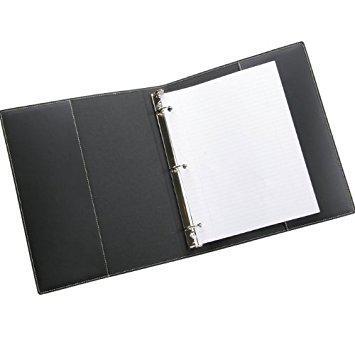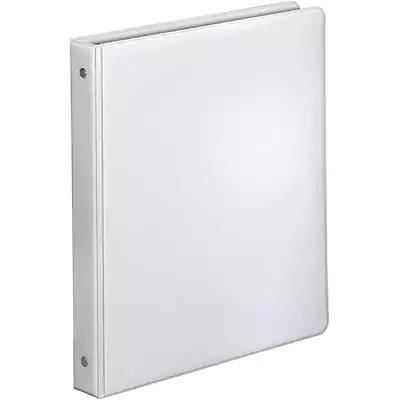The first image is the image on the left, the second image is the image on the right. Given the left and right images, does the statement "The right image contains exactly one white binder standing vertically." hold true? Answer yes or no. Yes. The first image is the image on the left, the second image is the image on the right. Assess this claim about the two images: "There is a sticker on the spine of one of the binders.". Correct or not? Answer yes or no. No. 